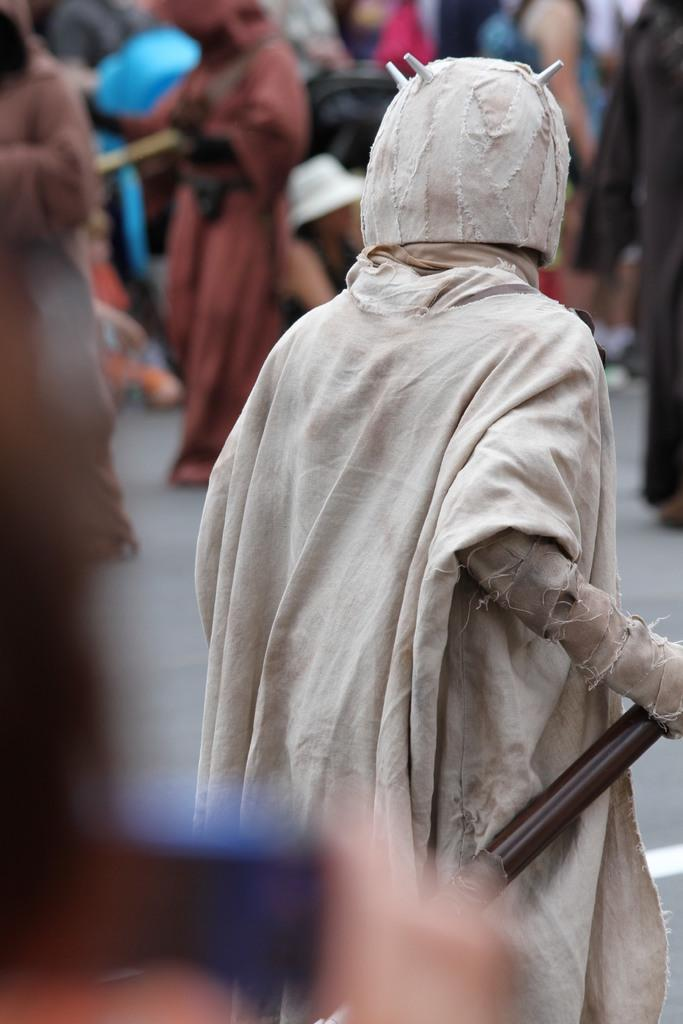What is the person in the image holding? The person is holding an object. Can you describe the actions of the people in the image? There are people standing in the image. What type of prose is being read by the person in the image? There is no indication in the image that the person is reading any prose, as the facts provided do not mention any reading material. 